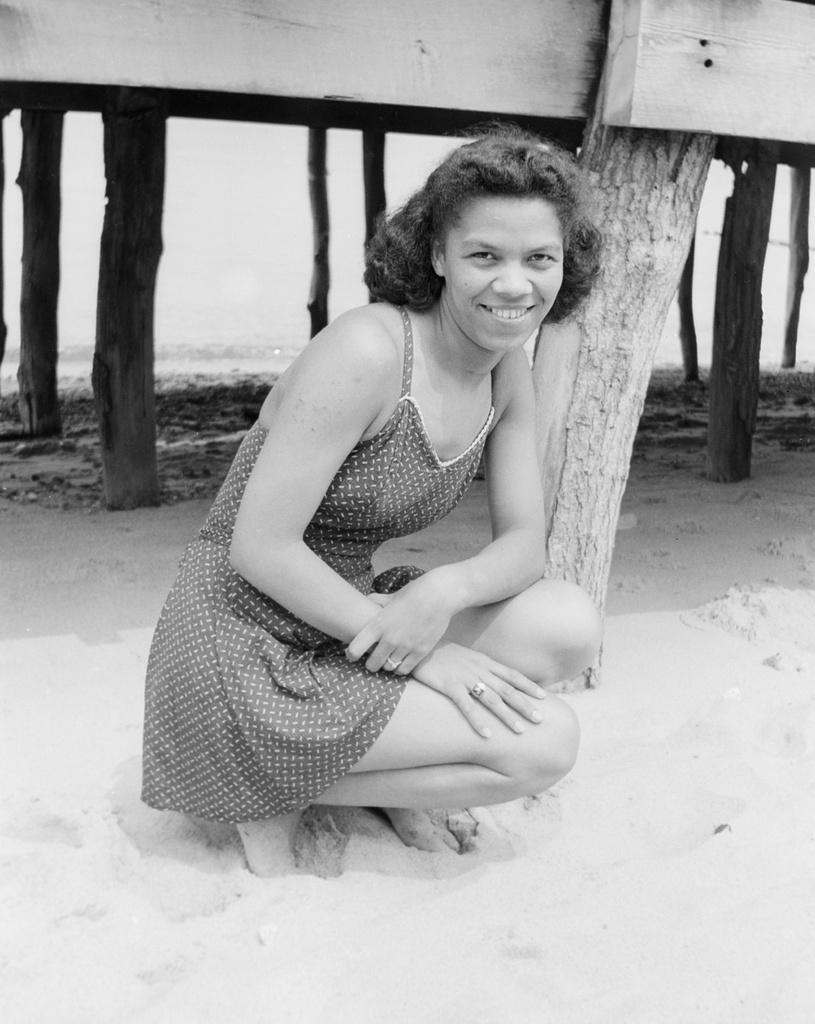Who is present in the image? There is a woman in the image. What is the woman's facial expression? The woman is smiling. What can be seen in the background of the image? There are tree trunks in the background of the image. What is the color scheme of the image? The image is black and white in color. What type of weather can be seen in the image? The image is black and white, so it is not possible to determine the weather from the image. 